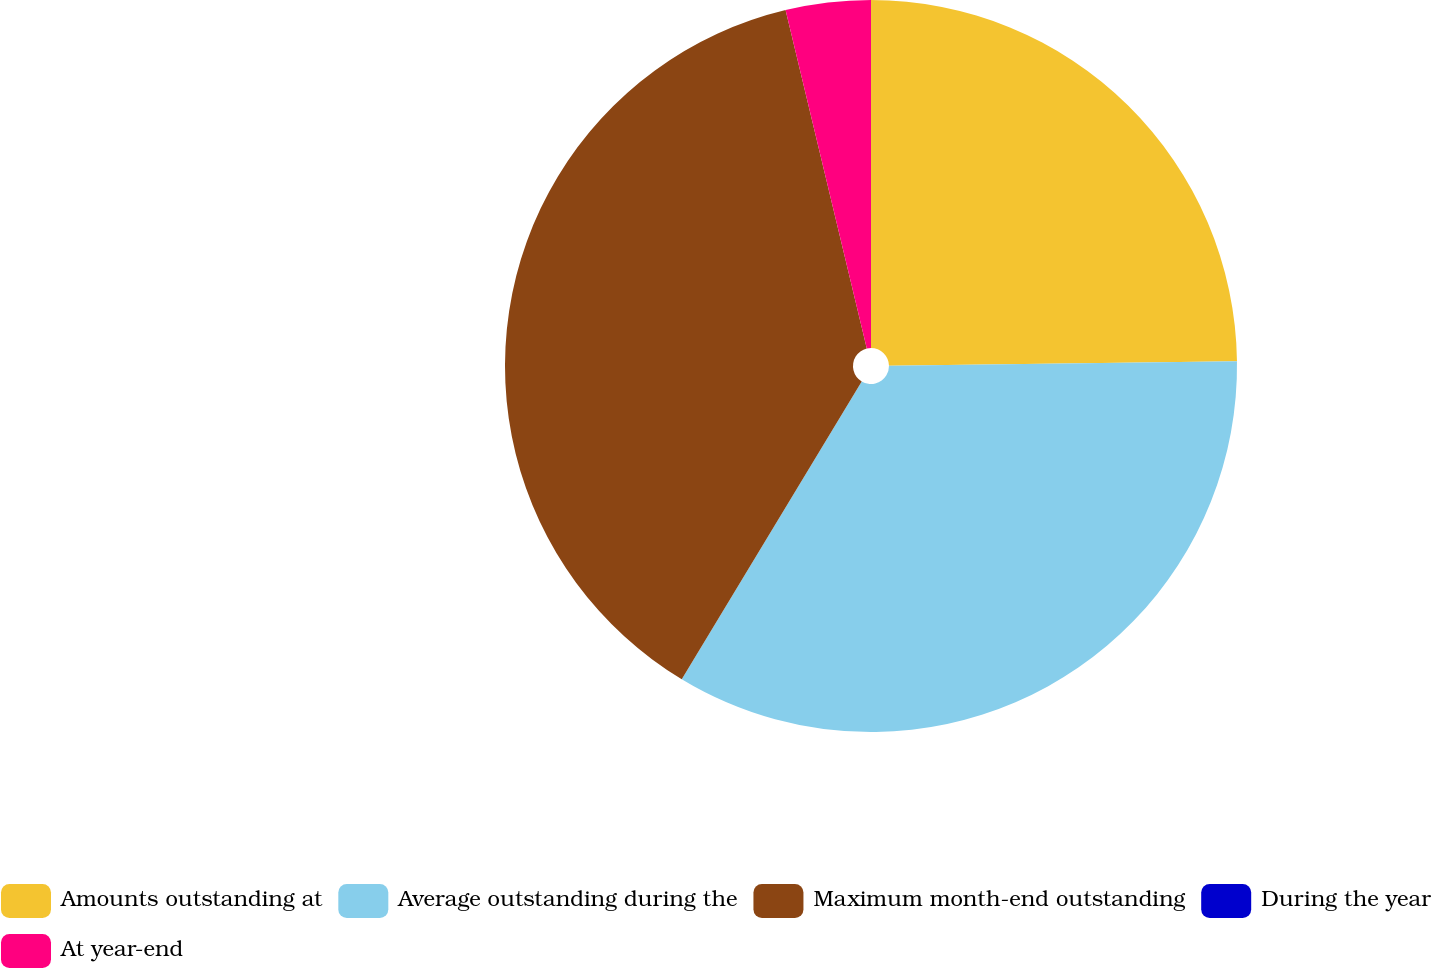<chart> <loc_0><loc_0><loc_500><loc_500><pie_chart><fcel>Amounts outstanding at<fcel>Average outstanding during the<fcel>Maximum month-end outstanding<fcel>During the year<fcel>At year-end<nl><fcel>24.79%<fcel>33.86%<fcel>37.6%<fcel>0.0%<fcel>3.75%<nl></chart> 